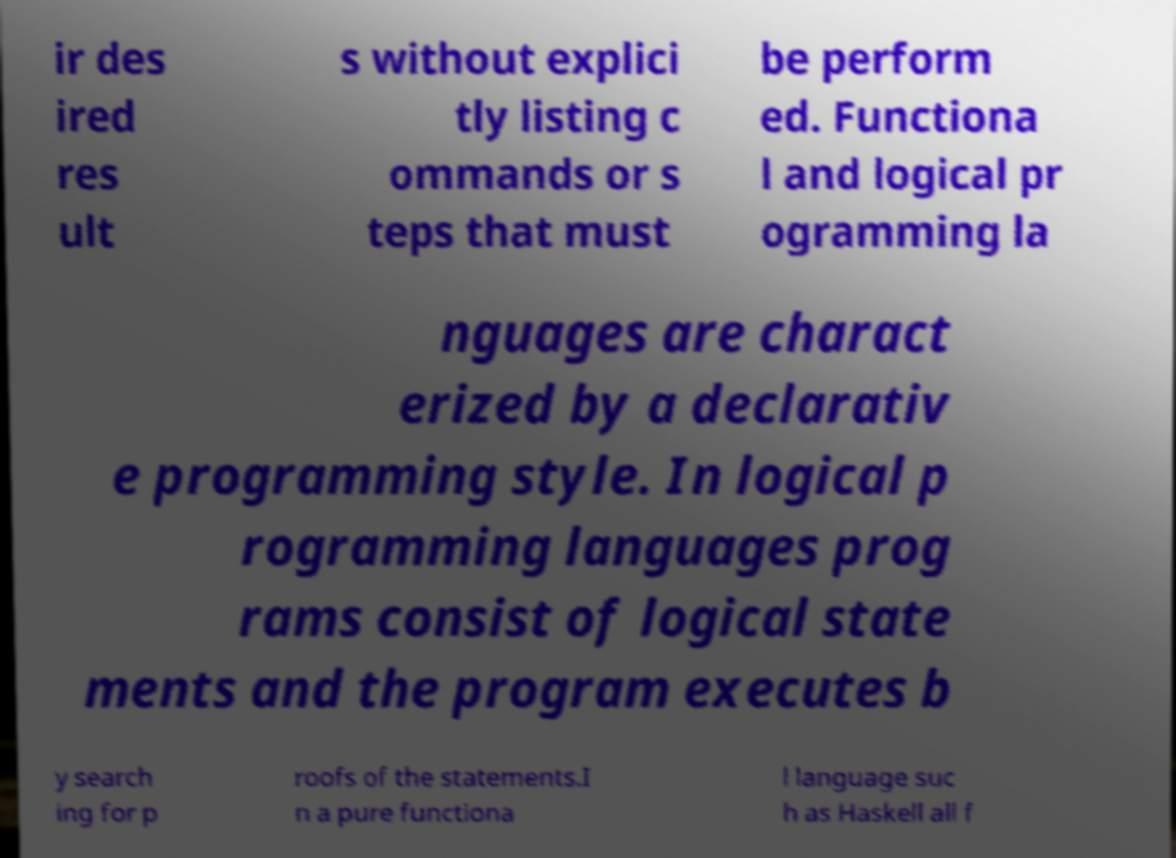There's text embedded in this image that I need extracted. Can you transcribe it verbatim? ir des ired res ult s without explici tly listing c ommands or s teps that must be perform ed. Functiona l and logical pr ogramming la nguages are charact erized by a declarativ e programming style. In logical p rogramming languages prog rams consist of logical state ments and the program executes b y search ing for p roofs of the statements.I n a pure functiona l language suc h as Haskell all f 